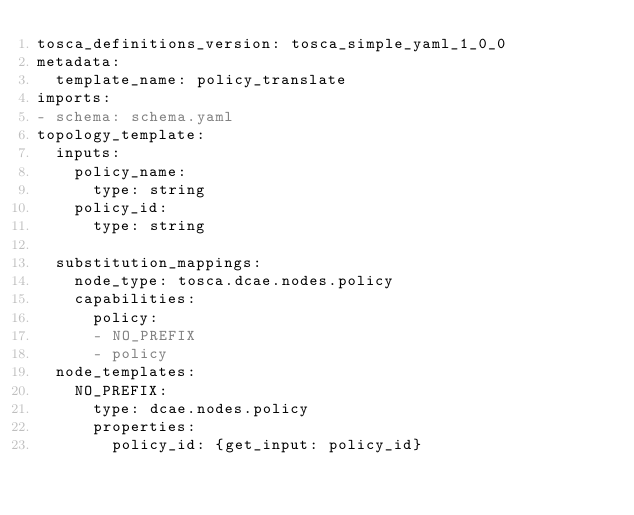Convert code to text. <code><loc_0><loc_0><loc_500><loc_500><_YAML_>tosca_definitions_version: tosca_simple_yaml_1_0_0
metadata:
  template_name: policy_translate
imports:
- schema: schema.yaml
topology_template:
  inputs: 
    policy_name: 
      type: string
    policy_id:
      type: string
   
  substitution_mappings:
    node_type: tosca.dcae.nodes.policy
    capabilities:
      policy:
      - NO_PREFIX
      - policy
  node_templates:
    NO_PREFIX:
      type: dcae.nodes.policy
      properties:
        policy_id: {get_input: policy_id}</code> 